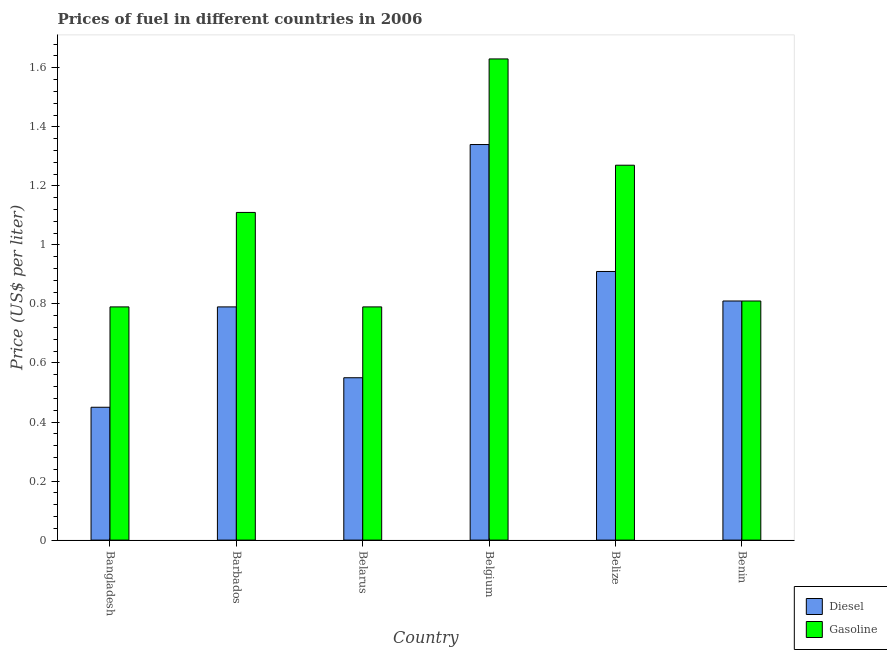How many groups of bars are there?
Your answer should be very brief. 6. How many bars are there on the 5th tick from the left?
Keep it short and to the point. 2. How many bars are there on the 1st tick from the right?
Keep it short and to the point. 2. What is the label of the 6th group of bars from the left?
Give a very brief answer. Benin. In how many cases, is the number of bars for a given country not equal to the number of legend labels?
Keep it short and to the point. 0. What is the gasoline price in Belize?
Your answer should be compact. 1.27. Across all countries, what is the maximum gasoline price?
Offer a terse response. 1.63. Across all countries, what is the minimum diesel price?
Your answer should be very brief. 0.45. In which country was the diesel price maximum?
Provide a succinct answer. Belgium. In which country was the gasoline price minimum?
Offer a terse response. Bangladesh. What is the total gasoline price in the graph?
Keep it short and to the point. 6.4. What is the difference between the gasoline price in Bangladesh and that in Benin?
Your response must be concise. -0.02. What is the difference between the diesel price in Bangladesh and the gasoline price in Belize?
Make the answer very short. -0.82. What is the average gasoline price per country?
Provide a succinct answer. 1.07. What is the difference between the diesel price and gasoline price in Barbados?
Make the answer very short. -0.32. What is the ratio of the gasoline price in Barbados to that in Belarus?
Your response must be concise. 1.41. What is the difference between the highest and the second highest gasoline price?
Provide a short and direct response. 0.36. What is the difference between the highest and the lowest diesel price?
Offer a very short reply. 0.89. In how many countries, is the diesel price greater than the average diesel price taken over all countries?
Your response must be concise. 3. What does the 1st bar from the left in Belgium represents?
Offer a very short reply. Diesel. What does the 1st bar from the right in Barbados represents?
Make the answer very short. Gasoline. How many countries are there in the graph?
Provide a short and direct response. 6. What is the difference between two consecutive major ticks on the Y-axis?
Your response must be concise. 0.2. Does the graph contain grids?
Ensure brevity in your answer.  No. Where does the legend appear in the graph?
Provide a succinct answer. Bottom right. What is the title of the graph?
Offer a very short reply. Prices of fuel in different countries in 2006. What is the label or title of the X-axis?
Make the answer very short. Country. What is the label or title of the Y-axis?
Your answer should be compact. Price (US$ per liter). What is the Price (US$ per liter) in Diesel in Bangladesh?
Your answer should be very brief. 0.45. What is the Price (US$ per liter) of Gasoline in Bangladesh?
Give a very brief answer. 0.79. What is the Price (US$ per liter) of Diesel in Barbados?
Your answer should be very brief. 0.79. What is the Price (US$ per liter) of Gasoline in Barbados?
Offer a terse response. 1.11. What is the Price (US$ per liter) in Diesel in Belarus?
Give a very brief answer. 0.55. What is the Price (US$ per liter) in Gasoline in Belarus?
Your answer should be very brief. 0.79. What is the Price (US$ per liter) of Diesel in Belgium?
Make the answer very short. 1.34. What is the Price (US$ per liter) of Gasoline in Belgium?
Give a very brief answer. 1.63. What is the Price (US$ per liter) of Diesel in Belize?
Offer a very short reply. 0.91. What is the Price (US$ per liter) in Gasoline in Belize?
Offer a terse response. 1.27. What is the Price (US$ per liter) of Diesel in Benin?
Make the answer very short. 0.81. What is the Price (US$ per liter) in Gasoline in Benin?
Keep it short and to the point. 0.81. Across all countries, what is the maximum Price (US$ per liter) in Diesel?
Your answer should be compact. 1.34. Across all countries, what is the maximum Price (US$ per liter) of Gasoline?
Provide a short and direct response. 1.63. Across all countries, what is the minimum Price (US$ per liter) in Diesel?
Provide a succinct answer. 0.45. Across all countries, what is the minimum Price (US$ per liter) in Gasoline?
Give a very brief answer. 0.79. What is the total Price (US$ per liter) of Diesel in the graph?
Your response must be concise. 4.85. What is the total Price (US$ per liter) of Gasoline in the graph?
Offer a very short reply. 6.4. What is the difference between the Price (US$ per liter) of Diesel in Bangladesh and that in Barbados?
Provide a succinct answer. -0.34. What is the difference between the Price (US$ per liter) of Gasoline in Bangladesh and that in Barbados?
Your answer should be compact. -0.32. What is the difference between the Price (US$ per liter) of Diesel in Bangladesh and that in Belgium?
Provide a short and direct response. -0.89. What is the difference between the Price (US$ per liter) of Gasoline in Bangladesh and that in Belgium?
Keep it short and to the point. -0.84. What is the difference between the Price (US$ per liter) of Diesel in Bangladesh and that in Belize?
Make the answer very short. -0.46. What is the difference between the Price (US$ per liter) of Gasoline in Bangladesh and that in Belize?
Your answer should be very brief. -0.48. What is the difference between the Price (US$ per liter) in Diesel in Bangladesh and that in Benin?
Provide a succinct answer. -0.36. What is the difference between the Price (US$ per liter) in Gasoline in Bangladesh and that in Benin?
Provide a short and direct response. -0.02. What is the difference between the Price (US$ per liter) in Diesel in Barbados and that in Belarus?
Make the answer very short. 0.24. What is the difference between the Price (US$ per liter) of Gasoline in Barbados and that in Belarus?
Your answer should be compact. 0.32. What is the difference between the Price (US$ per liter) of Diesel in Barbados and that in Belgium?
Offer a terse response. -0.55. What is the difference between the Price (US$ per liter) of Gasoline in Barbados and that in Belgium?
Provide a short and direct response. -0.52. What is the difference between the Price (US$ per liter) of Diesel in Barbados and that in Belize?
Offer a terse response. -0.12. What is the difference between the Price (US$ per liter) in Gasoline in Barbados and that in Belize?
Your answer should be very brief. -0.16. What is the difference between the Price (US$ per liter) of Diesel in Barbados and that in Benin?
Ensure brevity in your answer.  -0.02. What is the difference between the Price (US$ per liter) of Diesel in Belarus and that in Belgium?
Give a very brief answer. -0.79. What is the difference between the Price (US$ per liter) of Gasoline in Belarus and that in Belgium?
Offer a terse response. -0.84. What is the difference between the Price (US$ per liter) of Diesel in Belarus and that in Belize?
Your answer should be compact. -0.36. What is the difference between the Price (US$ per liter) in Gasoline in Belarus and that in Belize?
Your response must be concise. -0.48. What is the difference between the Price (US$ per liter) of Diesel in Belarus and that in Benin?
Provide a short and direct response. -0.26. What is the difference between the Price (US$ per liter) in Gasoline in Belarus and that in Benin?
Your answer should be very brief. -0.02. What is the difference between the Price (US$ per liter) of Diesel in Belgium and that in Belize?
Make the answer very short. 0.43. What is the difference between the Price (US$ per liter) of Gasoline in Belgium and that in Belize?
Offer a very short reply. 0.36. What is the difference between the Price (US$ per liter) of Diesel in Belgium and that in Benin?
Keep it short and to the point. 0.53. What is the difference between the Price (US$ per liter) in Gasoline in Belgium and that in Benin?
Provide a short and direct response. 0.82. What is the difference between the Price (US$ per liter) of Gasoline in Belize and that in Benin?
Provide a short and direct response. 0.46. What is the difference between the Price (US$ per liter) of Diesel in Bangladesh and the Price (US$ per liter) of Gasoline in Barbados?
Give a very brief answer. -0.66. What is the difference between the Price (US$ per liter) of Diesel in Bangladesh and the Price (US$ per liter) of Gasoline in Belarus?
Your answer should be very brief. -0.34. What is the difference between the Price (US$ per liter) of Diesel in Bangladesh and the Price (US$ per liter) of Gasoline in Belgium?
Provide a short and direct response. -1.18. What is the difference between the Price (US$ per liter) in Diesel in Bangladesh and the Price (US$ per liter) in Gasoline in Belize?
Your answer should be very brief. -0.82. What is the difference between the Price (US$ per liter) of Diesel in Bangladesh and the Price (US$ per liter) of Gasoline in Benin?
Give a very brief answer. -0.36. What is the difference between the Price (US$ per liter) in Diesel in Barbados and the Price (US$ per liter) in Gasoline in Belgium?
Your answer should be very brief. -0.84. What is the difference between the Price (US$ per liter) of Diesel in Barbados and the Price (US$ per liter) of Gasoline in Belize?
Your answer should be compact. -0.48. What is the difference between the Price (US$ per liter) of Diesel in Barbados and the Price (US$ per liter) of Gasoline in Benin?
Offer a very short reply. -0.02. What is the difference between the Price (US$ per liter) in Diesel in Belarus and the Price (US$ per liter) in Gasoline in Belgium?
Your answer should be compact. -1.08. What is the difference between the Price (US$ per liter) in Diesel in Belarus and the Price (US$ per liter) in Gasoline in Belize?
Your answer should be very brief. -0.72. What is the difference between the Price (US$ per liter) of Diesel in Belarus and the Price (US$ per liter) of Gasoline in Benin?
Provide a short and direct response. -0.26. What is the difference between the Price (US$ per liter) in Diesel in Belgium and the Price (US$ per liter) in Gasoline in Belize?
Provide a short and direct response. 0.07. What is the difference between the Price (US$ per liter) in Diesel in Belgium and the Price (US$ per liter) in Gasoline in Benin?
Provide a succinct answer. 0.53. What is the average Price (US$ per liter) in Diesel per country?
Offer a very short reply. 0.81. What is the average Price (US$ per liter) in Gasoline per country?
Provide a short and direct response. 1.07. What is the difference between the Price (US$ per liter) of Diesel and Price (US$ per liter) of Gasoline in Bangladesh?
Your answer should be very brief. -0.34. What is the difference between the Price (US$ per liter) in Diesel and Price (US$ per liter) in Gasoline in Barbados?
Offer a very short reply. -0.32. What is the difference between the Price (US$ per liter) of Diesel and Price (US$ per liter) of Gasoline in Belarus?
Make the answer very short. -0.24. What is the difference between the Price (US$ per liter) of Diesel and Price (US$ per liter) of Gasoline in Belgium?
Your answer should be very brief. -0.29. What is the difference between the Price (US$ per liter) of Diesel and Price (US$ per liter) of Gasoline in Belize?
Make the answer very short. -0.36. What is the difference between the Price (US$ per liter) in Diesel and Price (US$ per liter) in Gasoline in Benin?
Your answer should be compact. 0. What is the ratio of the Price (US$ per liter) of Diesel in Bangladesh to that in Barbados?
Offer a terse response. 0.57. What is the ratio of the Price (US$ per liter) in Gasoline in Bangladesh to that in Barbados?
Keep it short and to the point. 0.71. What is the ratio of the Price (US$ per liter) in Diesel in Bangladesh to that in Belarus?
Offer a terse response. 0.82. What is the ratio of the Price (US$ per liter) in Gasoline in Bangladesh to that in Belarus?
Make the answer very short. 1. What is the ratio of the Price (US$ per liter) of Diesel in Bangladesh to that in Belgium?
Ensure brevity in your answer.  0.34. What is the ratio of the Price (US$ per liter) of Gasoline in Bangladesh to that in Belgium?
Your answer should be very brief. 0.48. What is the ratio of the Price (US$ per liter) of Diesel in Bangladesh to that in Belize?
Your answer should be very brief. 0.49. What is the ratio of the Price (US$ per liter) of Gasoline in Bangladesh to that in Belize?
Provide a short and direct response. 0.62. What is the ratio of the Price (US$ per liter) of Diesel in Bangladesh to that in Benin?
Offer a very short reply. 0.56. What is the ratio of the Price (US$ per liter) of Gasoline in Bangladesh to that in Benin?
Make the answer very short. 0.98. What is the ratio of the Price (US$ per liter) of Diesel in Barbados to that in Belarus?
Offer a very short reply. 1.44. What is the ratio of the Price (US$ per liter) in Gasoline in Barbados to that in Belarus?
Ensure brevity in your answer.  1.41. What is the ratio of the Price (US$ per liter) in Diesel in Barbados to that in Belgium?
Your answer should be very brief. 0.59. What is the ratio of the Price (US$ per liter) of Gasoline in Barbados to that in Belgium?
Give a very brief answer. 0.68. What is the ratio of the Price (US$ per liter) in Diesel in Barbados to that in Belize?
Your answer should be very brief. 0.87. What is the ratio of the Price (US$ per liter) of Gasoline in Barbados to that in Belize?
Offer a very short reply. 0.87. What is the ratio of the Price (US$ per liter) of Diesel in Barbados to that in Benin?
Keep it short and to the point. 0.98. What is the ratio of the Price (US$ per liter) of Gasoline in Barbados to that in Benin?
Offer a terse response. 1.37. What is the ratio of the Price (US$ per liter) of Diesel in Belarus to that in Belgium?
Give a very brief answer. 0.41. What is the ratio of the Price (US$ per liter) in Gasoline in Belarus to that in Belgium?
Offer a very short reply. 0.48. What is the ratio of the Price (US$ per liter) of Diesel in Belarus to that in Belize?
Give a very brief answer. 0.6. What is the ratio of the Price (US$ per liter) of Gasoline in Belarus to that in Belize?
Your response must be concise. 0.62. What is the ratio of the Price (US$ per liter) of Diesel in Belarus to that in Benin?
Keep it short and to the point. 0.68. What is the ratio of the Price (US$ per liter) in Gasoline in Belarus to that in Benin?
Make the answer very short. 0.98. What is the ratio of the Price (US$ per liter) of Diesel in Belgium to that in Belize?
Your answer should be very brief. 1.47. What is the ratio of the Price (US$ per liter) in Gasoline in Belgium to that in Belize?
Give a very brief answer. 1.28. What is the ratio of the Price (US$ per liter) of Diesel in Belgium to that in Benin?
Provide a short and direct response. 1.65. What is the ratio of the Price (US$ per liter) of Gasoline in Belgium to that in Benin?
Keep it short and to the point. 2.01. What is the ratio of the Price (US$ per liter) in Diesel in Belize to that in Benin?
Your answer should be compact. 1.12. What is the ratio of the Price (US$ per liter) in Gasoline in Belize to that in Benin?
Your answer should be compact. 1.57. What is the difference between the highest and the second highest Price (US$ per liter) of Diesel?
Your response must be concise. 0.43. What is the difference between the highest and the second highest Price (US$ per liter) of Gasoline?
Offer a very short reply. 0.36. What is the difference between the highest and the lowest Price (US$ per liter) of Diesel?
Provide a short and direct response. 0.89. What is the difference between the highest and the lowest Price (US$ per liter) in Gasoline?
Provide a succinct answer. 0.84. 